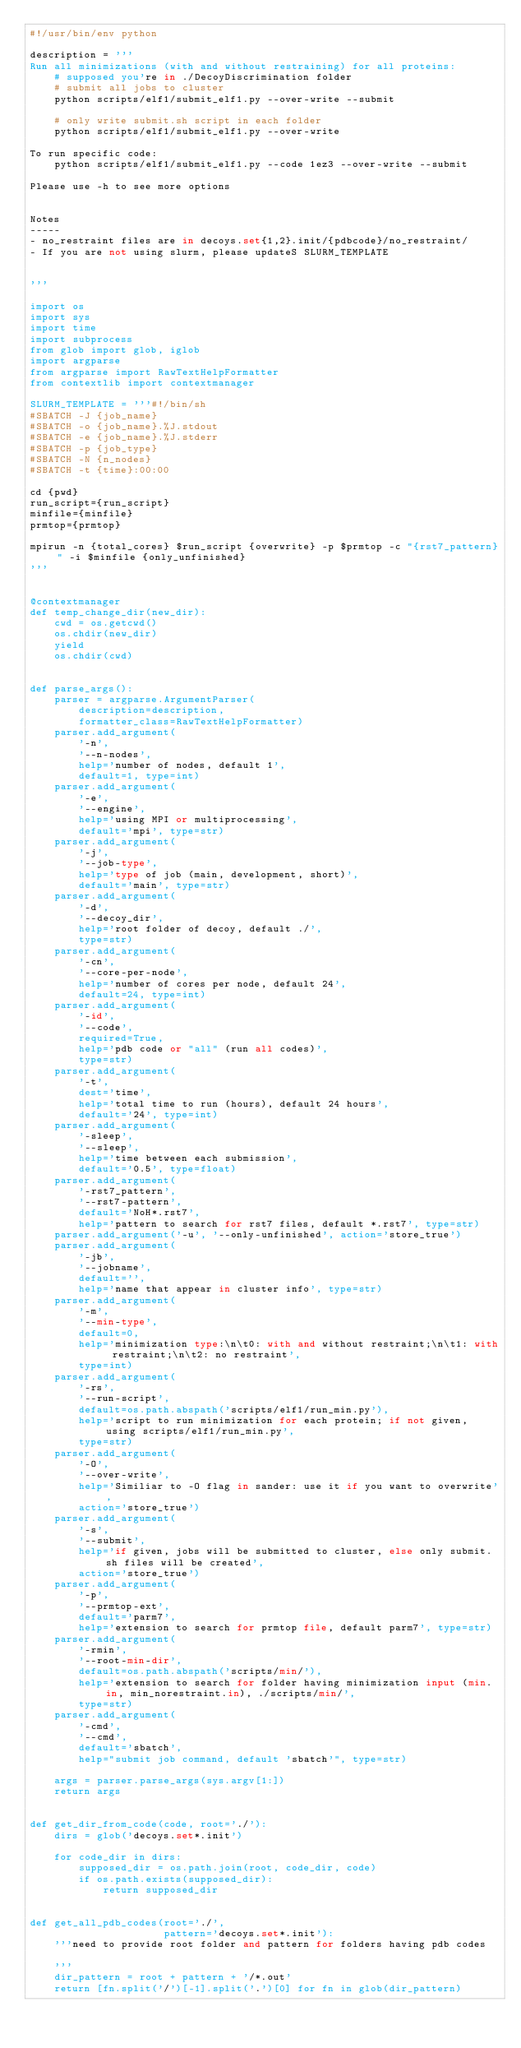<code> <loc_0><loc_0><loc_500><loc_500><_Python_>#!/usr/bin/env python

description = '''
Run all minimizations (with and without restraining) for all proteins:
    # supposed you're in ./DecoyDiscrimination folder
    # submit all jobs to cluster
    python scripts/elf1/submit_elf1.py --over-write --submit

    # only write submit.sh script in each folder
    python scripts/elf1/submit_elf1.py --over-write

To run specific code:
    python scripts/elf1/submit_elf1.py --code 1ez3 --over-write --submit

Please use -h to see more options


Notes
-----
- no_restraint files are in decoys.set{1,2}.init/{pdbcode}/no_restraint/
- If you are not using slurm, please updateS SLURM_TEMPLATE


'''

import os
import sys
import time
import subprocess
from glob import glob, iglob
import argparse
from argparse import RawTextHelpFormatter
from contextlib import contextmanager

SLURM_TEMPLATE = '''#!/bin/sh
#SBATCH -J {job_name}
#SBATCH -o {job_name}.%J.stdout
#SBATCH -e {job_name}.%J.stderr
#SBATCH -p {job_type}
#SBATCH -N {n_nodes}
#SBATCH -t {time}:00:00

cd {pwd}
run_script={run_script}
minfile={minfile}
prmtop={prmtop}

mpirun -n {total_cores} $run_script {overwrite} -p $prmtop -c "{rst7_pattern}" -i $minfile {only_unfinished}
'''


@contextmanager
def temp_change_dir(new_dir):
    cwd = os.getcwd()
    os.chdir(new_dir)
    yield
    os.chdir(cwd)


def parse_args():
    parser = argparse.ArgumentParser(
        description=description,
        formatter_class=RawTextHelpFormatter)
    parser.add_argument(
        '-n',
        '--n-nodes',
        help='number of nodes, default 1',
        default=1, type=int)
    parser.add_argument(
        '-e',
        '--engine',
        help='using MPI or multiprocessing',
        default='mpi', type=str)
    parser.add_argument(
        '-j',
        '--job-type',
        help='type of job (main, development, short)', 
        default='main', type=str)
    parser.add_argument(
        '-d',
        '--decoy_dir',
        help='root folder of decoy, default ./',
        type=str)
    parser.add_argument(
        '-cn',
        '--core-per-node',
        help='number of cores per node, default 24',
        default=24, type=int)
    parser.add_argument(
        '-id',
        '--code',
        required=True,
        help='pdb code or "all" (run all codes)',
        type=str)
    parser.add_argument(
        '-t',
        dest='time',
        help='total time to run (hours), default 24 hours',
        default='24', type=int)
    parser.add_argument(
        '-sleep',
        '--sleep',
        help='time between each submission',
        default='0.5', type=float)
    parser.add_argument(
        '-rst7_pattern',
        '--rst7-pattern',
        default='NoH*.rst7',
        help='pattern to search for rst7 files, default *.rst7', type=str)
    parser.add_argument('-u', '--only-unfinished', action='store_true')
    parser.add_argument(
        '-jb',
        '--jobname',
        default='',
        help='name that appear in cluster info', type=str)
    parser.add_argument(
        '-m',
        '--min-type',
        default=0,
        help='minimization type:\n\t0: with and without restraint;\n\t1: with restraint;\n\t2: no restraint',
        type=int)
    parser.add_argument(
        '-rs',
        '--run-script',
        default=os.path.abspath('scripts/elf1/run_min.py'),
        help='script to run minimization for each protein; if not given, using scripts/elf1/run_min.py',
        type=str)
    parser.add_argument(
        '-O',
        '--over-write',
        help='Similiar to -O flag in sander: use it if you want to overwrite',
        action='store_true')
    parser.add_argument(
        '-s',
        '--submit',
        help='if given, jobs will be submitted to cluster, else only submit.sh files will be created',
        action='store_true')
    parser.add_argument(
        '-p',
        '--prmtop-ext',
        default='parm7',
        help='extension to search for prmtop file, default parm7', type=str)
    parser.add_argument(
        '-rmin',
        '--root-min-dir',
        default=os.path.abspath('scripts/min/'),
        help='extension to search for folder having minimization input (min.in, min_norestraint.in), ./scripts/min/',
        type=str)
    parser.add_argument(
        '-cmd',
        '--cmd',
        default='sbatch',
        help="submit job command, default 'sbatch'", type=str)

    args = parser.parse_args(sys.argv[1:])
    return args


def get_dir_from_code(code, root='./'):
    dirs = glob('decoys.set*.init')

    for code_dir in dirs:
        supposed_dir = os.path.join(root, code_dir, code)
        if os.path.exists(supposed_dir):
            return supposed_dir


def get_all_pdb_codes(root='./',
                      pattern='decoys.set*.init'):
    '''need to provide root folder and pattern for folders having pdb codes

    '''
    dir_pattern = root + pattern + '/*.out'
    return [fn.split('/')[-1].split('.')[0] for fn in glob(dir_pattern)</code> 